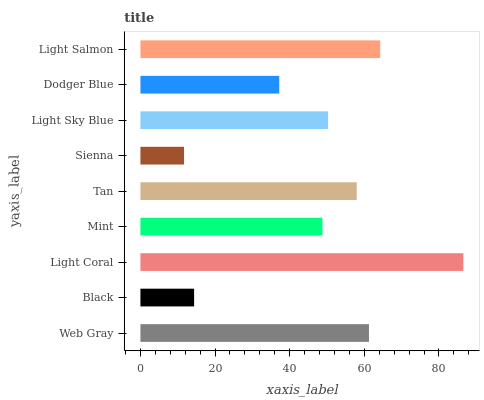Is Sienna the minimum?
Answer yes or no. Yes. Is Light Coral the maximum?
Answer yes or no. Yes. Is Black the minimum?
Answer yes or no. No. Is Black the maximum?
Answer yes or no. No. Is Web Gray greater than Black?
Answer yes or no. Yes. Is Black less than Web Gray?
Answer yes or no. Yes. Is Black greater than Web Gray?
Answer yes or no. No. Is Web Gray less than Black?
Answer yes or no. No. Is Light Sky Blue the high median?
Answer yes or no. Yes. Is Light Sky Blue the low median?
Answer yes or no. Yes. Is Light Coral the high median?
Answer yes or no. No. Is Light Coral the low median?
Answer yes or no. No. 